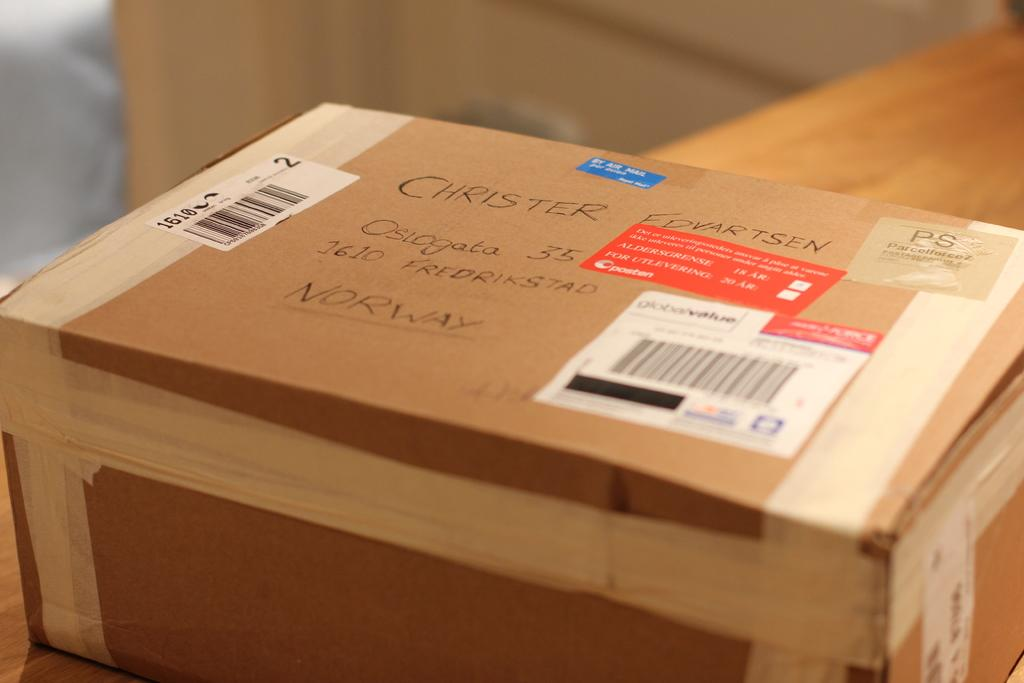<image>
Render a clear and concise summary of the photo. A box is addressed to a Norway address. 